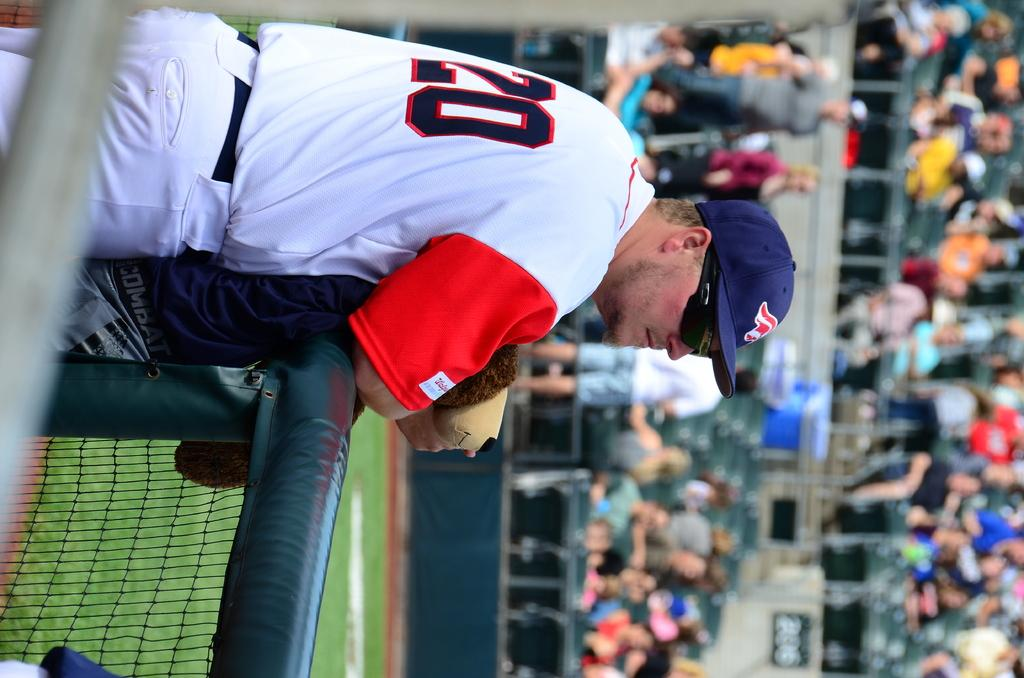<image>
Create a compact narrative representing the image presented. The coach wearing number 20 watches his baseball team from the dugout. 